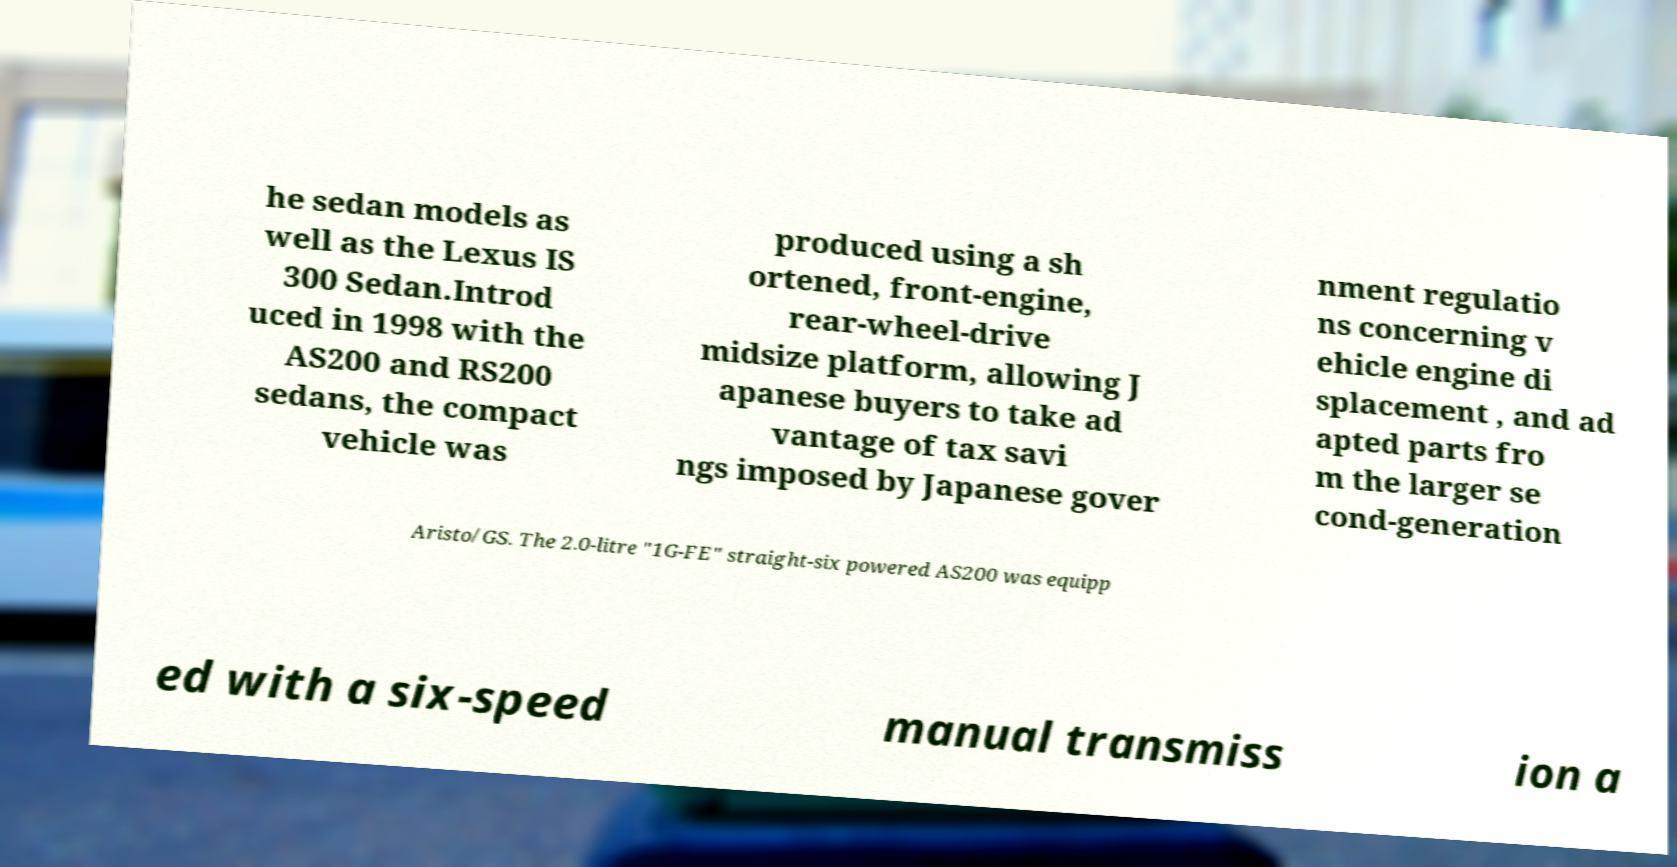Can you accurately transcribe the text from the provided image for me? he sedan models as well as the Lexus IS 300 Sedan.Introd uced in 1998 with the AS200 and RS200 sedans, the compact vehicle was produced using a sh ortened, front-engine, rear-wheel-drive midsize platform, allowing J apanese buyers to take ad vantage of tax savi ngs imposed by Japanese gover nment regulatio ns concerning v ehicle engine di splacement , and ad apted parts fro m the larger se cond-generation Aristo/GS. The 2.0-litre "1G-FE" straight-six powered AS200 was equipp ed with a six-speed manual transmiss ion a 